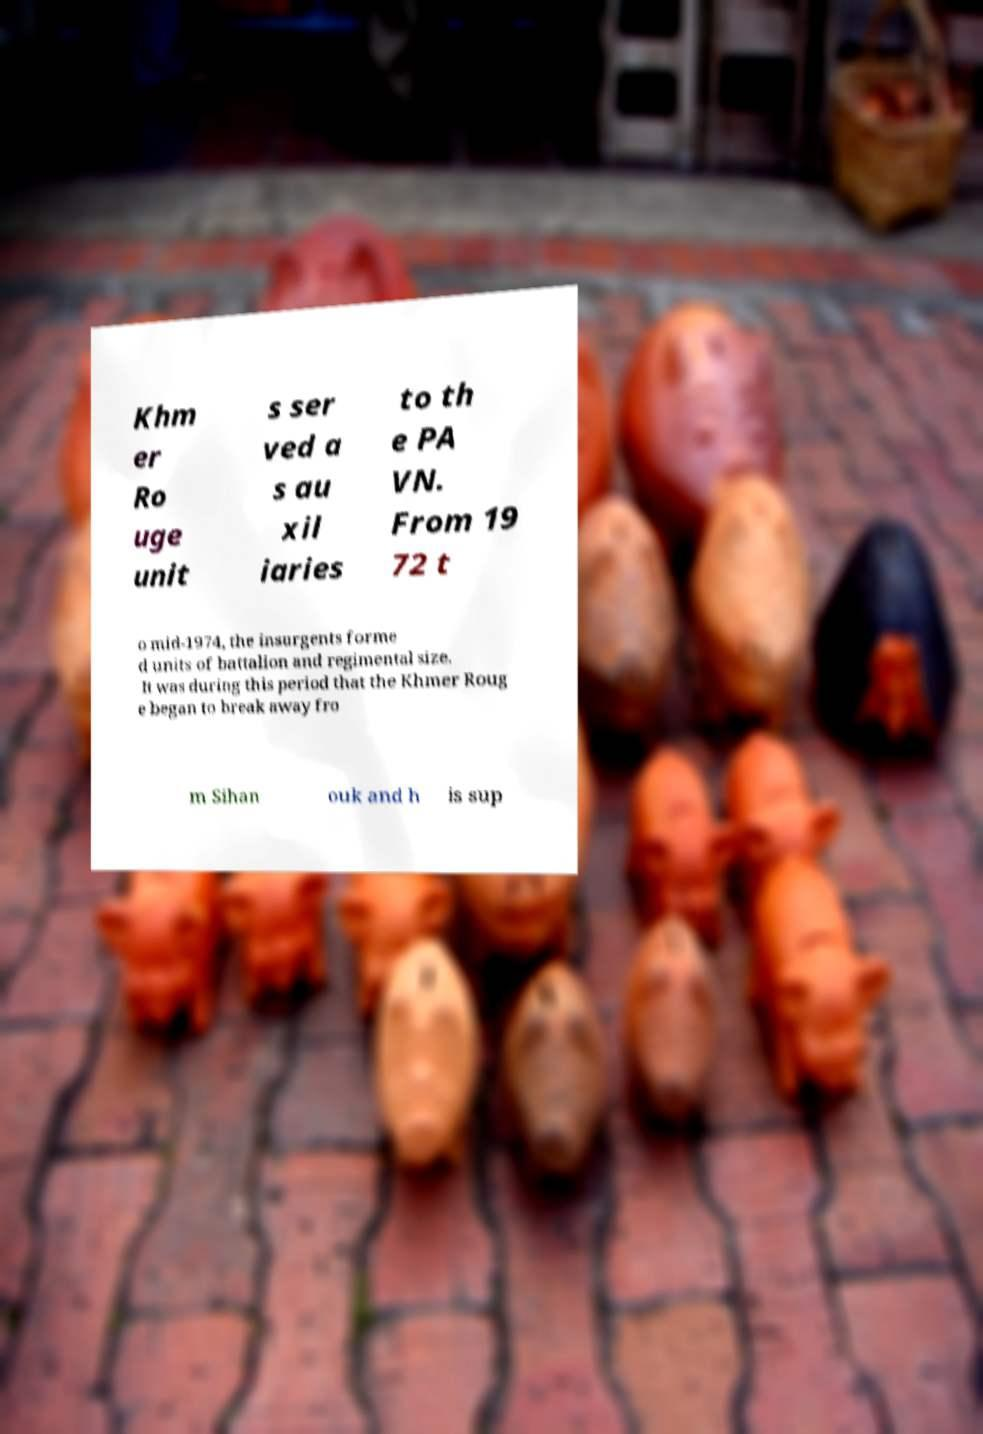Please identify and transcribe the text found in this image. Khm er Ro uge unit s ser ved a s au xil iaries to th e PA VN. From 19 72 t o mid-1974, the insurgents forme d units of battalion and regimental size. It was during this period that the Khmer Roug e began to break away fro m Sihan ouk and h is sup 